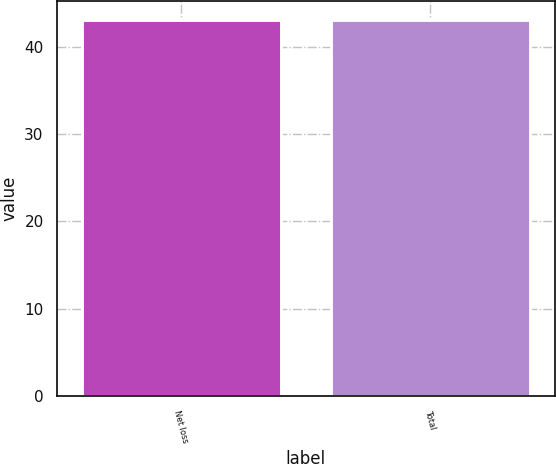Convert chart to OTSL. <chart><loc_0><loc_0><loc_500><loc_500><bar_chart><fcel>Net loss<fcel>Total<nl><fcel>43<fcel>43.1<nl></chart> 